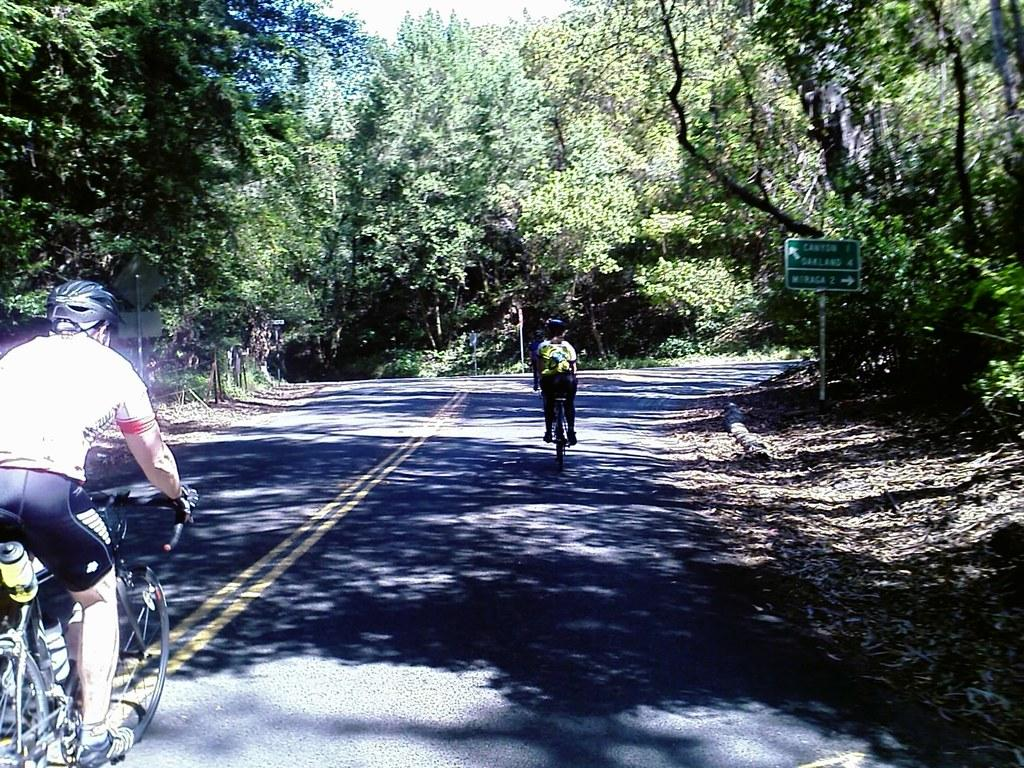What are the two people in the image doing? The two people in the image are riding bicycles on the road. What can be seen besides the people and bicycles in the image? There is a signboard, a fence, trees, and leaves on the ground in the image. What type of bell can be heard ringing in the image? There is no bell present in the image, and therefore no sound can be heard. 